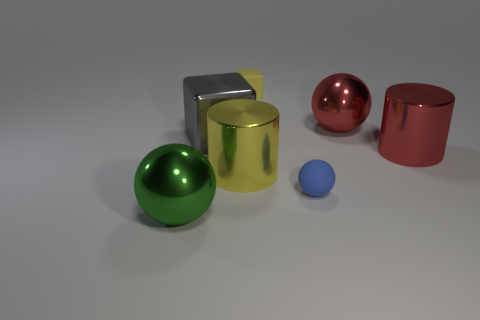Subtract all large red shiny balls. How many balls are left? 2 Add 2 large red metal cylinders. How many objects exist? 9 Subtract all gray blocks. How many blocks are left? 1 Subtract all cubes. How many objects are left? 5 Subtract 2 balls. How many balls are left? 1 Subtract all metal spheres. Subtract all tiny things. How many objects are left? 3 Add 7 red things. How many red things are left? 9 Add 4 big purple matte objects. How many big purple matte objects exist? 4 Subtract 0 brown blocks. How many objects are left? 7 Subtract all blue cylinders. Subtract all cyan balls. How many cylinders are left? 2 